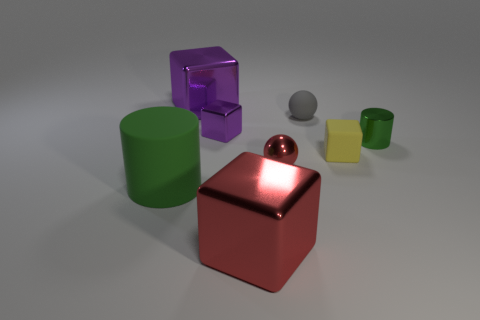Is there a tiny gray sphere that is on the left side of the large metal object in front of the green cylinder behind the red sphere? Upon examining the image, it seems there isn’t any tiny gray sphere located on the left side of the prominent metal cube, in front of the green cylinder, or behind the red sphere. The gray sphere is actually situated in a more central position relative to all the objects mentioned. 